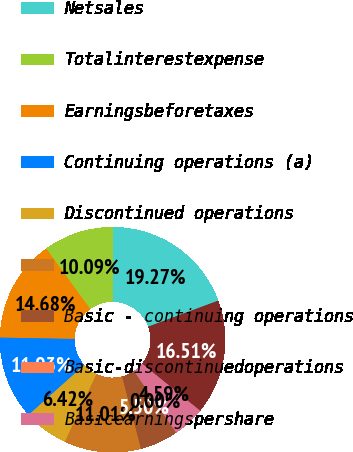<chart> <loc_0><loc_0><loc_500><loc_500><pie_chart><fcel>( in millions except per share<fcel>Netsales<fcel>Totalinterestexpense<fcel>Earningsbeforetaxes<fcel>Continuing operations (a)<fcel>Discontinued operations<fcel>Unnamed: 6<fcel>Basic - continuing operations<fcel>Basic-discontinuedoperations<fcel>Basicearningspershare<nl><fcel>16.51%<fcel>19.27%<fcel>10.09%<fcel>14.68%<fcel>11.93%<fcel>6.42%<fcel>11.01%<fcel>5.5%<fcel>0.0%<fcel>4.59%<nl></chart> 